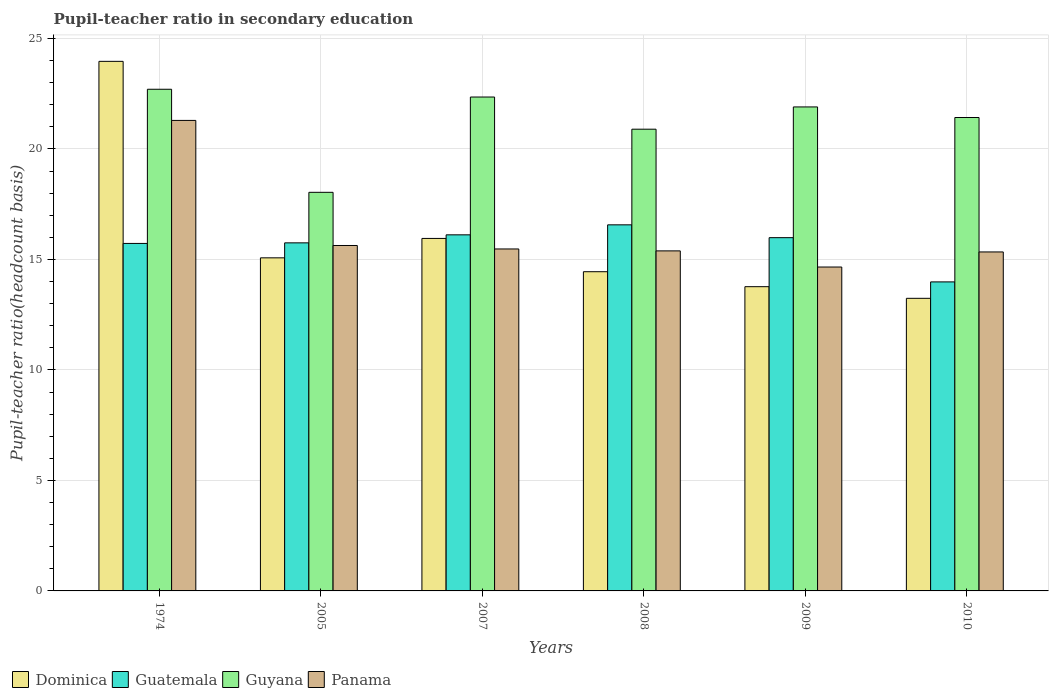How many different coloured bars are there?
Provide a succinct answer. 4. How many bars are there on the 2nd tick from the left?
Give a very brief answer. 4. How many bars are there on the 6th tick from the right?
Keep it short and to the point. 4. What is the label of the 5th group of bars from the left?
Your response must be concise. 2009. In how many cases, is the number of bars for a given year not equal to the number of legend labels?
Ensure brevity in your answer.  0. What is the pupil-teacher ratio in secondary education in Guatemala in 2010?
Your response must be concise. 13.98. Across all years, what is the maximum pupil-teacher ratio in secondary education in Panama?
Offer a very short reply. 21.29. Across all years, what is the minimum pupil-teacher ratio in secondary education in Guatemala?
Offer a terse response. 13.98. In which year was the pupil-teacher ratio in secondary education in Panama maximum?
Your answer should be very brief. 1974. What is the total pupil-teacher ratio in secondary education in Guatemala in the graph?
Your response must be concise. 94.12. What is the difference between the pupil-teacher ratio in secondary education in Panama in 2007 and that in 2010?
Your answer should be compact. 0.14. What is the difference between the pupil-teacher ratio in secondary education in Panama in 2010 and the pupil-teacher ratio in secondary education in Guatemala in 1974?
Make the answer very short. -0.39. What is the average pupil-teacher ratio in secondary education in Dominica per year?
Ensure brevity in your answer.  16.07. In the year 2008, what is the difference between the pupil-teacher ratio in secondary education in Dominica and pupil-teacher ratio in secondary education in Panama?
Ensure brevity in your answer.  -0.94. What is the ratio of the pupil-teacher ratio in secondary education in Guatemala in 2009 to that in 2010?
Provide a succinct answer. 1.14. Is the difference between the pupil-teacher ratio in secondary education in Dominica in 2008 and 2009 greater than the difference between the pupil-teacher ratio in secondary education in Panama in 2008 and 2009?
Keep it short and to the point. No. What is the difference between the highest and the second highest pupil-teacher ratio in secondary education in Guyana?
Give a very brief answer. 0.35. What is the difference between the highest and the lowest pupil-teacher ratio in secondary education in Guatemala?
Your answer should be very brief. 2.58. What does the 4th bar from the left in 2009 represents?
Give a very brief answer. Panama. What does the 2nd bar from the right in 2010 represents?
Your response must be concise. Guyana. Is it the case that in every year, the sum of the pupil-teacher ratio in secondary education in Dominica and pupil-teacher ratio in secondary education in Guatemala is greater than the pupil-teacher ratio in secondary education in Guyana?
Provide a succinct answer. Yes. Are all the bars in the graph horizontal?
Your answer should be compact. No. How many years are there in the graph?
Ensure brevity in your answer.  6. Are the values on the major ticks of Y-axis written in scientific E-notation?
Your answer should be very brief. No. How are the legend labels stacked?
Give a very brief answer. Horizontal. What is the title of the graph?
Offer a very short reply. Pupil-teacher ratio in secondary education. Does "Guatemala" appear as one of the legend labels in the graph?
Your answer should be very brief. Yes. What is the label or title of the X-axis?
Keep it short and to the point. Years. What is the label or title of the Y-axis?
Make the answer very short. Pupil-teacher ratio(headcount basis). What is the Pupil-teacher ratio(headcount basis) of Dominica in 1974?
Give a very brief answer. 23.96. What is the Pupil-teacher ratio(headcount basis) of Guatemala in 1974?
Provide a short and direct response. 15.72. What is the Pupil-teacher ratio(headcount basis) in Guyana in 1974?
Ensure brevity in your answer.  22.7. What is the Pupil-teacher ratio(headcount basis) of Panama in 1974?
Make the answer very short. 21.29. What is the Pupil-teacher ratio(headcount basis) of Dominica in 2005?
Your answer should be compact. 15.07. What is the Pupil-teacher ratio(headcount basis) in Guatemala in 2005?
Offer a terse response. 15.75. What is the Pupil-teacher ratio(headcount basis) in Guyana in 2005?
Make the answer very short. 18.04. What is the Pupil-teacher ratio(headcount basis) in Panama in 2005?
Provide a succinct answer. 15.63. What is the Pupil-teacher ratio(headcount basis) of Dominica in 2007?
Offer a terse response. 15.95. What is the Pupil-teacher ratio(headcount basis) in Guatemala in 2007?
Provide a succinct answer. 16.11. What is the Pupil-teacher ratio(headcount basis) of Guyana in 2007?
Give a very brief answer. 22.35. What is the Pupil-teacher ratio(headcount basis) of Panama in 2007?
Keep it short and to the point. 15.47. What is the Pupil-teacher ratio(headcount basis) of Dominica in 2008?
Provide a succinct answer. 14.44. What is the Pupil-teacher ratio(headcount basis) in Guatemala in 2008?
Offer a very short reply. 16.57. What is the Pupil-teacher ratio(headcount basis) in Guyana in 2008?
Provide a short and direct response. 20.89. What is the Pupil-teacher ratio(headcount basis) in Panama in 2008?
Your answer should be compact. 15.39. What is the Pupil-teacher ratio(headcount basis) in Dominica in 2009?
Give a very brief answer. 13.77. What is the Pupil-teacher ratio(headcount basis) of Guatemala in 2009?
Provide a short and direct response. 15.99. What is the Pupil-teacher ratio(headcount basis) in Guyana in 2009?
Provide a short and direct response. 21.9. What is the Pupil-teacher ratio(headcount basis) in Panama in 2009?
Provide a short and direct response. 14.66. What is the Pupil-teacher ratio(headcount basis) in Dominica in 2010?
Your answer should be compact. 13.24. What is the Pupil-teacher ratio(headcount basis) in Guatemala in 2010?
Provide a succinct answer. 13.98. What is the Pupil-teacher ratio(headcount basis) in Guyana in 2010?
Your response must be concise. 21.42. What is the Pupil-teacher ratio(headcount basis) of Panama in 2010?
Ensure brevity in your answer.  15.34. Across all years, what is the maximum Pupil-teacher ratio(headcount basis) of Dominica?
Your answer should be compact. 23.96. Across all years, what is the maximum Pupil-teacher ratio(headcount basis) of Guatemala?
Offer a very short reply. 16.57. Across all years, what is the maximum Pupil-teacher ratio(headcount basis) in Guyana?
Keep it short and to the point. 22.7. Across all years, what is the maximum Pupil-teacher ratio(headcount basis) in Panama?
Make the answer very short. 21.29. Across all years, what is the minimum Pupil-teacher ratio(headcount basis) in Dominica?
Offer a terse response. 13.24. Across all years, what is the minimum Pupil-teacher ratio(headcount basis) in Guatemala?
Offer a very short reply. 13.98. Across all years, what is the minimum Pupil-teacher ratio(headcount basis) in Guyana?
Give a very brief answer. 18.04. Across all years, what is the minimum Pupil-teacher ratio(headcount basis) in Panama?
Your response must be concise. 14.66. What is the total Pupil-teacher ratio(headcount basis) of Dominica in the graph?
Your answer should be compact. 96.44. What is the total Pupil-teacher ratio(headcount basis) in Guatemala in the graph?
Provide a succinct answer. 94.12. What is the total Pupil-teacher ratio(headcount basis) of Guyana in the graph?
Your answer should be very brief. 127.3. What is the total Pupil-teacher ratio(headcount basis) in Panama in the graph?
Your answer should be compact. 97.78. What is the difference between the Pupil-teacher ratio(headcount basis) in Dominica in 1974 and that in 2005?
Keep it short and to the point. 8.89. What is the difference between the Pupil-teacher ratio(headcount basis) of Guatemala in 1974 and that in 2005?
Your answer should be very brief. -0.03. What is the difference between the Pupil-teacher ratio(headcount basis) in Guyana in 1974 and that in 2005?
Make the answer very short. 4.66. What is the difference between the Pupil-teacher ratio(headcount basis) of Panama in 1974 and that in 2005?
Ensure brevity in your answer.  5.66. What is the difference between the Pupil-teacher ratio(headcount basis) of Dominica in 1974 and that in 2007?
Your response must be concise. 8.01. What is the difference between the Pupil-teacher ratio(headcount basis) of Guatemala in 1974 and that in 2007?
Make the answer very short. -0.39. What is the difference between the Pupil-teacher ratio(headcount basis) in Guyana in 1974 and that in 2007?
Provide a short and direct response. 0.35. What is the difference between the Pupil-teacher ratio(headcount basis) of Panama in 1974 and that in 2007?
Keep it short and to the point. 5.82. What is the difference between the Pupil-teacher ratio(headcount basis) of Dominica in 1974 and that in 2008?
Your answer should be very brief. 9.52. What is the difference between the Pupil-teacher ratio(headcount basis) of Guatemala in 1974 and that in 2008?
Give a very brief answer. -0.84. What is the difference between the Pupil-teacher ratio(headcount basis) in Guyana in 1974 and that in 2008?
Keep it short and to the point. 1.81. What is the difference between the Pupil-teacher ratio(headcount basis) of Panama in 1974 and that in 2008?
Give a very brief answer. 5.9. What is the difference between the Pupil-teacher ratio(headcount basis) of Dominica in 1974 and that in 2009?
Keep it short and to the point. 10.2. What is the difference between the Pupil-teacher ratio(headcount basis) in Guatemala in 1974 and that in 2009?
Keep it short and to the point. -0.26. What is the difference between the Pupil-teacher ratio(headcount basis) of Guyana in 1974 and that in 2009?
Offer a very short reply. 0.8. What is the difference between the Pupil-teacher ratio(headcount basis) in Panama in 1974 and that in 2009?
Ensure brevity in your answer.  6.63. What is the difference between the Pupil-teacher ratio(headcount basis) of Dominica in 1974 and that in 2010?
Your response must be concise. 10.72. What is the difference between the Pupil-teacher ratio(headcount basis) of Guatemala in 1974 and that in 2010?
Your answer should be compact. 1.74. What is the difference between the Pupil-teacher ratio(headcount basis) in Guyana in 1974 and that in 2010?
Your answer should be compact. 1.28. What is the difference between the Pupil-teacher ratio(headcount basis) in Panama in 1974 and that in 2010?
Provide a succinct answer. 5.95. What is the difference between the Pupil-teacher ratio(headcount basis) of Dominica in 2005 and that in 2007?
Your answer should be very brief. -0.88. What is the difference between the Pupil-teacher ratio(headcount basis) of Guatemala in 2005 and that in 2007?
Provide a short and direct response. -0.36. What is the difference between the Pupil-teacher ratio(headcount basis) in Guyana in 2005 and that in 2007?
Give a very brief answer. -4.31. What is the difference between the Pupil-teacher ratio(headcount basis) in Panama in 2005 and that in 2007?
Your answer should be very brief. 0.16. What is the difference between the Pupil-teacher ratio(headcount basis) of Dominica in 2005 and that in 2008?
Offer a terse response. 0.63. What is the difference between the Pupil-teacher ratio(headcount basis) in Guatemala in 2005 and that in 2008?
Provide a succinct answer. -0.82. What is the difference between the Pupil-teacher ratio(headcount basis) of Guyana in 2005 and that in 2008?
Your response must be concise. -2.86. What is the difference between the Pupil-teacher ratio(headcount basis) in Panama in 2005 and that in 2008?
Provide a succinct answer. 0.24. What is the difference between the Pupil-teacher ratio(headcount basis) in Dominica in 2005 and that in 2009?
Your response must be concise. 1.31. What is the difference between the Pupil-teacher ratio(headcount basis) of Guatemala in 2005 and that in 2009?
Offer a very short reply. -0.24. What is the difference between the Pupil-teacher ratio(headcount basis) in Guyana in 2005 and that in 2009?
Keep it short and to the point. -3.86. What is the difference between the Pupil-teacher ratio(headcount basis) in Panama in 2005 and that in 2009?
Provide a short and direct response. 0.97. What is the difference between the Pupil-teacher ratio(headcount basis) of Dominica in 2005 and that in 2010?
Provide a succinct answer. 1.83. What is the difference between the Pupil-teacher ratio(headcount basis) in Guatemala in 2005 and that in 2010?
Make the answer very short. 1.77. What is the difference between the Pupil-teacher ratio(headcount basis) of Guyana in 2005 and that in 2010?
Make the answer very short. -3.39. What is the difference between the Pupil-teacher ratio(headcount basis) of Panama in 2005 and that in 2010?
Make the answer very short. 0.29. What is the difference between the Pupil-teacher ratio(headcount basis) of Dominica in 2007 and that in 2008?
Make the answer very short. 1.51. What is the difference between the Pupil-teacher ratio(headcount basis) of Guatemala in 2007 and that in 2008?
Give a very brief answer. -0.45. What is the difference between the Pupil-teacher ratio(headcount basis) in Guyana in 2007 and that in 2008?
Ensure brevity in your answer.  1.46. What is the difference between the Pupil-teacher ratio(headcount basis) of Panama in 2007 and that in 2008?
Provide a succinct answer. 0.09. What is the difference between the Pupil-teacher ratio(headcount basis) in Dominica in 2007 and that in 2009?
Your answer should be very brief. 2.18. What is the difference between the Pupil-teacher ratio(headcount basis) in Guatemala in 2007 and that in 2009?
Your answer should be compact. 0.13. What is the difference between the Pupil-teacher ratio(headcount basis) of Guyana in 2007 and that in 2009?
Offer a very short reply. 0.45. What is the difference between the Pupil-teacher ratio(headcount basis) of Panama in 2007 and that in 2009?
Your answer should be very brief. 0.82. What is the difference between the Pupil-teacher ratio(headcount basis) of Dominica in 2007 and that in 2010?
Give a very brief answer. 2.71. What is the difference between the Pupil-teacher ratio(headcount basis) in Guatemala in 2007 and that in 2010?
Provide a short and direct response. 2.13. What is the difference between the Pupil-teacher ratio(headcount basis) of Guyana in 2007 and that in 2010?
Offer a terse response. 0.93. What is the difference between the Pupil-teacher ratio(headcount basis) in Panama in 2007 and that in 2010?
Make the answer very short. 0.14. What is the difference between the Pupil-teacher ratio(headcount basis) in Dominica in 2008 and that in 2009?
Provide a short and direct response. 0.68. What is the difference between the Pupil-teacher ratio(headcount basis) in Guatemala in 2008 and that in 2009?
Offer a terse response. 0.58. What is the difference between the Pupil-teacher ratio(headcount basis) of Guyana in 2008 and that in 2009?
Your response must be concise. -1.01. What is the difference between the Pupil-teacher ratio(headcount basis) of Panama in 2008 and that in 2009?
Ensure brevity in your answer.  0.73. What is the difference between the Pupil-teacher ratio(headcount basis) in Dominica in 2008 and that in 2010?
Ensure brevity in your answer.  1.2. What is the difference between the Pupil-teacher ratio(headcount basis) in Guatemala in 2008 and that in 2010?
Make the answer very short. 2.58. What is the difference between the Pupil-teacher ratio(headcount basis) in Guyana in 2008 and that in 2010?
Keep it short and to the point. -0.53. What is the difference between the Pupil-teacher ratio(headcount basis) of Panama in 2008 and that in 2010?
Keep it short and to the point. 0.05. What is the difference between the Pupil-teacher ratio(headcount basis) of Dominica in 2009 and that in 2010?
Provide a short and direct response. 0.53. What is the difference between the Pupil-teacher ratio(headcount basis) in Guatemala in 2009 and that in 2010?
Provide a short and direct response. 2. What is the difference between the Pupil-teacher ratio(headcount basis) in Guyana in 2009 and that in 2010?
Your answer should be very brief. 0.48. What is the difference between the Pupil-teacher ratio(headcount basis) in Panama in 2009 and that in 2010?
Provide a succinct answer. -0.68. What is the difference between the Pupil-teacher ratio(headcount basis) in Dominica in 1974 and the Pupil-teacher ratio(headcount basis) in Guatemala in 2005?
Provide a succinct answer. 8.21. What is the difference between the Pupil-teacher ratio(headcount basis) in Dominica in 1974 and the Pupil-teacher ratio(headcount basis) in Guyana in 2005?
Your response must be concise. 5.93. What is the difference between the Pupil-teacher ratio(headcount basis) in Dominica in 1974 and the Pupil-teacher ratio(headcount basis) in Panama in 2005?
Give a very brief answer. 8.33. What is the difference between the Pupil-teacher ratio(headcount basis) in Guatemala in 1974 and the Pupil-teacher ratio(headcount basis) in Guyana in 2005?
Your response must be concise. -2.31. What is the difference between the Pupil-teacher ratio(headcount basis) of Guatemala in 1974 and the Pupil-teacher ratio(headcount basis) of Panama in 2005?
Offer a terse response. 0.09. What is the difference between the Pupil-teacher ratio(headcount basis) of Guyana in 1974 and the Pupil-teacher ratio(headcount basis) of Panama in 2005?
Your response must be concise. 7.07. What is the difference between the Pupil-teacher ratio(headcount basis) of Dominica in 1974 and the Pupil-teacher ratio(headcount basis) of Guatemala in 2007?
Provide a succinct answer. 7.85. What is the difference between the Pupil-teacher ratio(headcount basis) of Dominica in 1974 and the Pupil-teacher ratio(headcount basis) of Guyana in 2007?
Your answer should be compact. 1.61. What is the difference between the Pupil-teacher ratio(headcount basis) of Dominica in 1974 and the Pupil-teacher ratio(headcount basis) of Panama in 2007?
Offer a very short reply. 8.49. What is the difference between the Pupil-teacher ratio(headcount basis) in Guatemala in 1974 and the Pupil-teacher ratio(headcount basis) in Guyana in 2007?
Provide a short and direct response. -6.62. What is the difference between the Pupil-teacher ratio(headcount basis) in Guatemala in 1974 and the Pupil-teacher ratio(headcount basis) in Panama in 2007?
Provide a succinct answer. 0.25. What is the difference between the Pupil-teacher ratio(headcount basis) of Guyana in 1974 and the Pupil-teacher ratio(headcount basis) of Panama in 2007?
Provide a short and direct response. 7.23. What is the difference between the Pupil-teacher ratio(headcount basis) in Dominica in 1974 and the Pupil-teacher ratio(headcount basis) in Guatemala in 2008?
Provide a short and direct response. 7.4. What is the difference between the Pupil-teacher ratio(headcount basis) of Dominica in 1974 and the Pupil-teacher ratio(headcount basis) of Guyana in 2008?
Your answer should be very brief. 3.07. What is the difference between the Pupil-teacher ratio(headcount basis) of Dominica in 1974 and the Pupil-teacher ratio(headcount basis) of Panama in 2008?
Provide a short and direct response. 8.58. What is the difference between the Pupil-teacher ratio(headcount basis) of Guatemala in 1974 and the Pupil-teacher ratio(headcount basis) of Guyana in 2008?
Your response must be concise. -5.17. What is the difference between the Pupil-teacher ratio(headcount basis) in Guatemala in 1974 and the Pupil-teacher ratio(headcount basis) in Panama in 2008?
Make the answer very short. 0.34. What is the difference between the Pupil-teacher ratio(headcount basis) in Guyana in 1974 and the Pupil-teacher ratio(headcount basis) in Panama in 2008?
Your answer should be compact. 7.31. What is the difference between the Pupil-teacher ratio(headcount basis) of Dominica in 1974 and the Pupil-teacher ratio(headcount basis) of Guatemala in 2009?
Your answer should be compact. 7.98. What is the difference between the Pupil-teacher ratio(headcount basis) of Dominica in 1974 and the Pupil-teacher ratio(headcount basis) of Guyana in 2009?
Offer a very short reply. 2.06. What is the difference between the Pupil-teacher ratio(headcount basis) in Dominica in 1974 and the Pupil-teacher ratio(headcount basis) in Panama in 2009?
Give a very brief answer. 9.31. What is the difference between the Pupil-teacher ratio(headcount basis) in Guatemala in 1974 and the Pupil-teacher ratio(headcount basis) in Guyana in 2009?
Keep it short and to the point. -6.18. What is the difference between the Pupil-teacher ratio(headcount basis) of Guatemala in 1974 and the Pupil-teacher ratio(headcount basis) of Panama in 2009?
Ensure brevity in your answer.  1.07. What is the difference between the Pupil-teacher ratio(headcount basis) of Guyana in 1974 and the Pupil-teacher ratio(headcount basis) of Panama in 2009?
Your answer should be compact. 8.04. What is the difference between the Pupil-teacher ratio(headcount basis) of Dominica in 1974 and the Pupil-teacher ratio(headcount basis) of Guatemala in 2010?
Give a very brief answer. 9.98. What is the difference between the Pupil-teacher ratio(headcount basis) of Dominica in 1974 and the Pupil-teacher ratio(headcount basis) of Guyana in 2010?
Give a very brief answer. 2.54. What is the difference between the Pupil-teacher ratio(headcount basis) in Dominica in 1974 and the Pupil-teacher ratio(headcount basis) in Panama in 2010?
Keep it short and to the point. 8.62. What is the difference between the Pupil-teacher ratio(headcount basis) of Guatemala in 1974 and the Pupil-teacher ratio(headcount basis) of Guyana in 2010?
Give a very brief answer. -5.7. What is the difference between the Pupil-teacher ratio(headcount basis) in Guatemala in 1974 and the Pupil-teacher ratio(headcount basis) in Panama in 2010?
Offer a very short reply. 0.39. What is the difference between the Pupil-teacher ratio(headcount basis) in Guyana in 1974 and the Pupil-teacher ratio(headcount basis) in Panama in 2010?
Offer a very short reply. 7.36. What is the difference between the Pupil-teacher ratio(headcount basis) in Dominica in 2005 and the Pupil-teacher ratio(headcount basis) in Guatemala in 2007?
Your response must be concise. -1.04. What is the difference between the Pupil-teacher ratio(headcount basis) in Dominica in 2005 and the Pupil-teacher ratio(headcount basis) in Guyana in 2007?
Keep it short and to the point. -7.28. What is the difference between the Pupil-teacher ratio(headcount basis) of Dominica in 2005 and the Pupil-teacher ratio(headcount basis) of Panama in 2007?
Give a very brief answer. -0.4. What is the difference between the Pupil-teacher ratio(headcount basis) in Guatemala in 2005 and the Pupil-teacher ratio(headcount basis) in Guyana in 2007?
Your answer should be very brief. -6.6. What is the difference between the Pupil-teacher ratio(headcount basis) in Guatemala in 2005 and the Pupil-teacher ratio(headcount basis) in Panama in 2007?
Offer a terse response. 0.28. What is the difference between the Pupil-teacher ratio(headcount basis) in Guyana in 2005 and the Pupil-teacher ratio(headcount basis) in Panama in 2007?
Provide a short and direct response. 2.56. What is the difference between the Pupil-teacher ratio(headcount basis) of Dominica in 2005 and the Pupil-teacher ratio(headcount basis) of Guatemala in 2008?
Provide a short and direct response. -1.49. What is the difference between the Pupil-teacher ratio(headcount basis) in Dominica in 2005 and the Pupil-teacher ratio(headcount basis) in Guyana in 2008?
Ensure brevity in your answer.  -5.82. What is the difference between the Pupil-teacher ratio(headcount basis) in Dominica in 2005 and the Pupil-teacher ratio(headcount basis) in Panama in 2008?
Provide a succinct answer. -0.31. What is the difference between the Pupil-teacher ratio(headcount basis) of Guatemala in 2005 and the Pupil-teacher ratio(headcount basis) of Guyana in 2008?
Make the answer very short. -5.14. What is the difference between the Pupil-teacher ratio(headcount basis) in Guatemala in 2005 and the Pupil-teacher ratio(headcount basis) in Panama in 2008?
Keep it short and to the point. 0.36. What is the difference between the Pupil-teacher ratio(headcount basis) in Guyana in 2005 and the Pupil-teacher ratio(headcount basis) in Panama in 2008?
Make the answer very short. 2.65. What is the difference between the Pupil-teacher ratio(headcount basis) of Dominica in 2005 and the Pupil-teacher ratio(headcount basis) of Guatemala in 2009?
Give a very brief answer. -0.91. What is the difference between the Pupil-teacher ratio(headcount basis) of Dominica in 2005 and the Pupil-teacher ratio(headcount basis) of Guyana in 2009?
Your answer should be compact. -6.83. What is the difference between the Pupil-teacher ratio(headcount basis) in Dominica in 2005 and the Pupil-teacher ratio(headcount basis) in Panama in 2009?
Make the answer very short. 0.42. What is the difference between the Pupil-teacher ratio(headcount basis) of Guatemala in 2005 and the Pupil-teacher ratio(headcount basis) of Guyana in 2009?
Your answer should be compact. -6.15. What is the difference between the Pupil-teacher ratio(headcount basis) of Guatemala in 2005 and the Pupil-teacher ratio(headcount basis) of Panama in 2009?
Give a very brief answer. 1.09. What is the difference between the Pupil-teacher ratio(headcount basis) in Guyana in 2005 and the Pupil-teacher ratio(headcount basis) in Panama in 2009?
Keep it short and to the point. 3.38. What is the difference between the Pupil-teacher ratio(headcount basis) of Dominica in 2005 and the Pupil-teacher ratio(headcount basis) of Guatemala in 2010?
Give a very brief answer. 1.09. What is the difference between the Pupil-teacher ratio(headcount basis) in Dominica in 2005 and the Pupil-teacher ratio(headcount basis) in Guyana in 2010?
Make the answer very short. -6.35. What is the difference between the Pupil-teacher ratio(headcount basis) in Dominica in 2005 and the Pupil-teacher ratio(headcount basis) in Panama in 2010?
Give a very brief answer. -0.27. What is the difference between the Pupil-teacher ratio(headcount basis) in Guatemala in 2005 and the Pupil-teacher ratio(headcount basis) in Guyana in 2010?
Ensure brevity in your answer.  -5.67. What is the difference between the Pupil-teacher ratio(headcount basis) of Guatemala in 2005 and the Pupil-teacher ratio(headcount basis) of Panama in 2010?
Your response must be concise. 0.41. What is the difference between the Pupil-teacher ratio(headcount basis) in Guyana in 2005 and the Pupil-teacher ratio(headcount basis) in Panama in 2010?
Provide a succinct answer. 2.7. What is the difference between the Pupil-teacher ratio(headcount basis) in Dominica in 2007 and the Pupil-teacher ratio(headcount basis) in Guatemala in 2008?
Provide a short and direct response. -0.61. What is the difference between the Pupil-teacher ratio(headcount basis) in Dominica in 2007 and the Pupil-teacher ratio(headcount basis) in Guyana in 2008?
Give a very brief answer. -4.94. What is the difference between the Pupil-teacher ratio(headcount basis) of Dominica in 2007 and the Pupil-teacher ratio(headcount basis) of Panama in 2008?
Provide a short and direct response. 0.56. What is the difference between the Pupil-teacher ratio(headcount basis) of Guatemala in 2007 and the Pupil-teacher ratio(headcount basis) of Guyana in 2008?
Your response must be concise. -4.78. What is the difference between the Pupil-teacher ratio(headcount basis) of Guatemala in 2007 and the Pupil-teacher ratio(headcount basis) of Panama in 2008?
Offer a terse response. 0.73. What is the difference between the Pupil-teacher ratio(headcount basis) of Guyana in 2007 and the Pupil-teacher ratio(headcount basis) of Panama in 2008?
Provide a succinct answer. 6.96. What is the difference between the Pupil-teacher ratio(headcount basis) in Dominica in 2007 and the Pupil-teacher ratio(headcount basis) in Guatemala in 2009?
Provide a short and direct response. -0.03. What is the difference between the Pupil-teacher ratio(headcount basis) of Dominica in 2007 and the Pupil-teacher ratio(headcount basis) of Guyana in 2009?
Offer a terse response. -5.95. What is the difference between the Pupil-teacher ratio(headcount basis) of Dominica in 2007 and the Pupil-teacher ratio(headcount basis) of Panama in 2009?
Your answer should be very brief. 1.29. What is the difference between the Pupil-teacher ratio(headcount basis) of Guatemala in 2007 and the Pupil-teacher ratio(headcount basis) of Guyana in 2009?
Make the answer very short. -5.79. What is the difference between the Pupil-teacher ratio(headcount basis) in Guatemala in 2007 and the Pupil-teacher ratio(headcount basis) in Panama in 2009?
Ensure brevity in your answer.  1.46. What is the difference between the Pupil-teacher ratio(headcount basis) of Guyana in 2007 and the Pupil-teacher ratio(headcount basis) of Panama in 2009?
Ensure brevity in your answer.  7.69. What is the difference between the Pupil-teacher ratio(headcount basis) of Dominica in 2007 and the Pupil-teacher ratio(headcount basis) of Guatemala in 2010?
Offer a very short reply. 1.97. What is the difference between the Pupil-teacher ratio(headcount basis) in Dominica in 2007 and the Pupil-teacher ratio(headcount basis) in Guyana in 2010?
Ensure brevity in your answer.  -5.47. What is the difference between the Pupil-teacher ratio(headcount basis) in Dominica in 2007 and the Pupil-teacher ratio(headcount basis) in Panama in 2010?
Ensure brevity in your answer.  0.61. What is the difference between the Pupil-teacher ratio(headcount basis) of Guatemala in 2007 and the Pupil-teacher ratio(headcount basis) of Guyana in 2010?
Keep it short and to the point. -5.31. What is the difference between the Pupil-teacher ratio(headcount basis) in Guatemala in 2007 and the Pupil-teacher ratio(headcount basis) in Panama in 2010?
Keep it short and to the point. 0.77. What is the difference between the Pupil-teacher ratio(headcount basis) of Guyana in 2007 and the Pupil-teacher ratio(headcount basis) of Panama in 2010?
Provide a succinct answer. 7.01. What is the difference between the Pupil-teacher ratio(headcount basis) in Dominica in 2008 and the Pupil-teacher ratio(headcount basis) in Guatemala in 2009?
Provide a short and direct response. -1.54. What is the difference between the Pupil-teacher ratio(headcount basis) of Dominica in 2008 and the Pupil-teacher ratio(headcount basis) of Guyana in 2009?
Keep it short and to the point. -7.46. What is the difference between the Pupil-teacher ratio(headcount basis) of Dominica in 2008 and the Pupil-teacher ratio(headcount basis) of Panama in 2009?
Your answer should be very brief. -0.21. What is the difference between the Pupil-teacher ratio(headcount basis) of Guatemala in 2008 and the Pupil-teacher ratio(headcount basis) of Guyana in 2009?
Your answer should be very brief. -5.34. What is the difference between the Pupil-teacher ratio(headcount basis) of Guatemala in 2008 and the Pupil-teacher ratio(headcount basis) of Panama in 2009?
Give a very brief answer. 1.91. What is the difference between the Pupil-teacher ratio(headcount basis) in Guyana in 2008 and the Pupil-teacher ratio(headcount basis) in Panama in 2009?
Provide a short and direct response. 6.24. What is the difference between the Pupil-teacher ratio(headcount basis) in Dominica in 2008 and the Pupil-teacher ratio(headcount basis) in Guatemala in 2010?
Provide a short and direct response. 0.46. What is the difference between the Pupil-teacher ratio(headcount basis) in Dominica in 2008 and the Pupil-teacher ratio(headcount basis) in Guyana in 2010?
Your response must be concise. -6.98. What is the difference between the Pupil-teacher ratio(headcount basis) in Dominica in 2008 and the Pupil-teacher ratio(headcount basis) in Panama in 2010?
Offer a very short reply. -0.89. What is the difference between the Pupil-teacher ratio(headcount basis) in Guatemala in 2008 and the Pupil-teacher ratio(headcount basis) in Guyana in 2010?
Your answer should be compact. -4.86. What is the difference between the Pupil-teacher ratio(headcount basis) in Guatemala in 2008 and the Pupil-teacher ratio(headcount basis) in Panama in 2010?
Ensure brevity in your answer.  1.23. What is the difference between the Pupil-teacher ratio(headcount basis) in Guyana in 2008 and the Pupil-teacher ratio(headcount basis) in Panama in 2010?
Offer a very short reply. 5.55. What is the difference between the Pupil-teacher ratio(headcount basis) in Dominica in 2009 and the Pupil-teacher ratio(headcount basis) in Guatemala in 2010?
Offer a very short reply. -0.22. What is the difference between the Pupil-teacher ratio(headcount basis) of Dominica in 2009 and the Pupil-teacher ratio(headcount basis) of Guyana in 2010?
Offer a very short reply. -7.66. What is the difference between the Pupil-teacher ratio(headcount basis) in Dominica in 2009 and the Pupil-teacher ratio(headcount basis) in Panama in 2010?
Your response must be concise. -1.57. What is the difference between the Pupil-teacher ratio(headcount basis) in Guatemala in 2009 and the Pupil-teacher ratio(headcount basis) in Guyana in 2010?
Provide a succinct answer. -5.44. What is the difference between the Pupil-teacher ratio(headcount basis) in Guatemala in 2009 and the Pupil-teacher ratio(headcount basis) in Panama in 2010?
Keep it short and to the point. 0.65. What is the difference between the Pupil-teacher ratio(headcount basis) of Guyana in 2009 and the Pupil-teacher ratio(headcount basis) of Panama in 2010?
Make the answer very short. 6.56. What is the average Pupil-teacher ratio(headcount basis) of Dominica per year?
Give a very brief answer. 16.07. What is the average Pupil-teacher ratio(headcount basis) of Guatemala per year?
Your response must be concise. 15.69. What is the average Pupil-teacher ratio(headcount basis) of Guyana per year?
Offer a very short reply. 21.22. What is the average Pupil-teacher ratio(headcount basis) of Panama per year?
Your answer should be very brief. 16.3. In the year 1974, what is the difference between the Pupil-teacher ratio(headcount basis) in Dominica and Pupil-teacher ratio(headcount basis) in Guatemala?
Make the answer very short. 8.24. In the year 1974, what is the difference between the Pupil-teacher ratio(headcount basis) in Dominica and Pupil-teacher ratio(headcount basis) in Guyana?
Give a very brief answer. 1.26. In the year 1974, what is the difference between the Pupil-teacher ratio(headcount basis) of Dominica and Pupil-teacher ratio(headcount basis) of Panama?
Offer a terse response. 2.67. In the year 1974, what is the difference between the Pupil-teacher ratio(headcount basis) in Guatemala and Pupil-teacher ratio(headcount basis) in Guyana?
Make the answer very short. -6.98. In the year 1974, what is the difference between the Pupil-teacher ratio(headcount basis) in Guatemala and Pupil-teacher ratio(headcount basis) in Panama?
Provide a succinct answer. -5.57. In the year 1974, what is the difference between the Pupil-teacher ratio(headcount basis) in Guyana and Pupil-teacher ratio(headcount basis) in Panama?
Provide a succinct answer. 1.41. In the year 2005, what is the difference between the Pupil-teacher ratio(headcount basis) of Dominica and Pupil-teacher ratio(headcount basis) of Guatemala?
Keep it short and to the point. -0.68. In the year 2005, what is the difference between the Pupil-teacher ratio(headcount basis) in Dominica and Pupil-teacher ratio(headcount basis) in Guyana?
Ensure brevity in your answer.  -2.96. In the year 2005, what is the difference between the Pupil-teacher ratio(headcount basis) in Dominica and Pupil-teacher ratio(headcount basis) in Panama?
Keep it short and to the point. -0.56. In the year 2005, what is the difference between the Pupil-teacher ratio(headcount basis) in Guatemala and Pupil-teacher ratio(headcount basis) in Guyana?
Your response must be concise. -2.29. In the year 2005, what is the difference between the Pupil-teacher ratio(headcount basis) in Guatemala and Pupil-teacher ratio(headcount basis) in Panama?
Make the answer very short. 0.12. In the year 2005, what is the difference between the Pupil-teacher ratio(headcount basis) in Guyana and Pupil-teacher ratio(headcount basis) in Panama?
Your response must be concise. 2.41. In the year 2007, what is the difference between the Pupil-teacher ratio(headcount basis) of Dominica and Pupil-teacher ratio(headcount basis) of Guatemala?
Give a very brief answer. -0.16. In the year 2007, what is the difference between the Pupil-teacher ratio(headcount basis) in Dominica and Pupil-teacher ratio(headcount basis) in Guyana?
Your answer should be very brief. -6.4. In the year 2007, what is the difference between the Pupil-teacher ratio(headcount basis) in Dominica and Pupil-teacher ratio(headcount basis) in Panama?
Your response must be concise. 0.48. In the year 2007, what is the difference between the Pupil-teacher ratio(headcount basis) in Guatemala and Pupil-teacher ratio(headcount basis) in Guyana?
Offer a terse response. -6.24. In the year 2007, what is the difference between the Pupil-teacher ratio(headcount basis) of Guatemala and Pupil-teacher ratio(headcount basis) of Panama?
Keep it short and to the point. 0.64. In the year 2007, what is the difference between the Pupil-teacher ratio(headcount basis) in Guyana and Pupil-teacher ratio(headcount basis) in Panama?
Offer a very short reply. 6.87. In the year 2008, what is the difference between the Pupil-teacher ratio(headcount basis) in Dominica and Pupil-teacher ratio(headcount basis) in Guatemala?
Your answer should be compact. -2.12. In the year 2008, what is the difference between the Pupil-teacher ratio(headcount basis) of Dominica and Pupil-teacher ratio(headcount basis) of Guyana?
Keep it short and to the point. -6.45. In the year 2008, what is the difference between the Pupil-teacher ratio(headcount basis) of Dominica and Pupil-teacher ratio(headcount basis) of Panama?
Offer a terse response. -0.94. In the year 2008, what is the difference between the Pupil-teacher ratio(headcount basis) in Guatemala and Pupil-teacher ratio(headcount basis) in Guyana?
Your answer should be compact. -4.33. In the year 2008, what is the difference between the Pupil-teacher ratio(headcount basis) in Guatemala and Pupil-teacher ratio(headcount basis) in Panama?
Provide a succinct answer. 1.18. In the year 2008, what is the difference between the Pupil-teacher ratio(headcount basis) in Guyana and Pupil-teacher ratio(headcount basis) in Panama?
Keep it short and to the point. 5.51. In the year 2009, what is the difference between the Pupil-teacher ratio(headcount basis) in Dominica and Pupil-teacher ratio(headcount basis) in Guatemala?
Offer a terse response. -2.22. In the year 2009, what is the difference between the Pupil-teacher ratio(headcount basis) in Dominica and Pupil-teacher ratio(headcount basis) in Guyana?
Give a very brief answer. -8.13. In the year 2009, what is the difference between the Pupil-teacher ratio(headcount basis) in Dominica and Pupil-teacher ratio(headcount basis) in Panama?
Keep it short and to the point. -0.89. In the year 2009, what is the difference between the Pupil-teacher ratio(headcount basis) in Guatemala and Pupil-teacher ratio(headcount basis) in Guyana?
Provide a short and direct response. -5.92. In the year 2009, what is the difference between the Pupil-teacher ratio(headcount basis) of Guatemala and Pupil-teacher ratio(headcount basis) of Panama?
Your answer should be very brief. 1.33. In the year 2009, what is the difference between the Pupil-teacher ratio(headcount basis) of Guyana and Pupil-teacher ratio(headcount basis) of Panama?
Keep it short and to the point. 7.24. In the year 2010, what is the difference between the Pupil-teacher ratio(headcount basis) in Dominica and Pupil-teacher ratio(headcount basis) in Guatemala?
Your answer should be compact. -0.74. In the year 2010, what is the difference between the Pupil-teacher ratio(headcount basis) of Dominica and Pupil-teacher ratio(headcount basis) of Guyana?
Provide a succinct answer. -8.18. In the year 2010, what is the difference between the Pupil-teacher ratio(headcount basis) in Dominica and Pupil-teacher ratio(headcount basis) in Panama?
Give a very brief answer. -2.1. In the year 2010, what is the difference between the Pupil-teacher ratio(headcount basis) in Guatemala and Pupil-teacher ratio(headcount basis) in Guyana?
Offer a very short reply. -7.44. In the year 2010, what is the difference between the Pupil-teacher ratio(headcount basis) in Guatemala and Pupil-teacher ratio(headcount basis) in Panama?
Offer a terse response. -1.36. In the year 2010, what is the difference between the Pupil-teacher ratio(headcount basis) in Guyana and Pupil-teacher ratio(headcount basis) in Panama?
Offer a terse response. 6.08. What is the ratio of the Pupil-teacher ratio(headcount basis) of Dominica in 1974 to that in 2005?
Make the answer very short. 1.59. What is the ratio of the Pupil-teacher ratio(headcount basis) in Guatemala in 1974 to that in 2005?
Provide a short and direct response. 1. What is the ratio of the Pupil-teacher ratio(headcount basis) in Guyana in 1974 to that in 2005?
Provide a short and direct response. 1.26. What is the ratio of the Pupil-teacher ratio(headcount basis) of Panama in 1974 to that in 2005?
Make the answer very short. 1.36. What is the ratio of the Pupil-teacher ratio(headcount basis) in Dominica in 1974 to that in 2007?
Your answer should be compact. 1.5. What is the ratio of the Pupil-teacher ratio(headcount basis) in Guatemala in 1974 to that in 2007?
Keep it short and to the point. 0.98. What is the ratio of the Pupil-teacher ratio(headcount basis) in Guyana in 1974 to that in 2007?
Ensure brevity in your answer.  1.02. What is the ratio of the Pupil-teacher ratio(headcount basis) in Panama in 1974 to that in 2007?
Ensure brevity in your answer.  1.38. What is the ratio of the Pupil-teacher ratio(headcount basis) in Dominica in 1974 to that in 2008?
Offer a very short reply. 1.66. What is the ratio of the Pupil-teacher ratio(headcount basis) of Guatemala in 1974 to that in 2008?
Provide a short and direct response. 0.95. What is the ratio of the Pupil-teacher ratio(headcount basis) of Guyana in 1974 to that in 2008?
Make the answer very short. 1.09. What is the ratio of the Pupil-teacher ratio(headcount basis) of Panama in 1974 to that in 2008?
Keep it short and to the point. 1.38. What is the ratio of the Pupil-teacher ratio(headcount basis) of Dominica in 1974 to that in 2009?
Offer a terse response. 1.74. What is the ratio of the Pupil-teacher ratio(headcount basis) in Guatemala in 1974 to that in 2009?
Keep it short and to the point. 0.98. What is the ratio of the Pupil-teacher ratio(headcount basis) of Guyana in 1974 to that in 2009?
Make the answer very short. 1.04. What is the ratio of the Pupil-teacher ratio(headcount basis) in Panama in 1974 to that in 2009?
Provide a short and direct response. 1.45. What is the ratio of the Pupil-teacher ratio(headcount basis) in Dominica in 1974 to that in 2010?
Your answer should be compact. 1.81. What is the ratio of the Pupil-teacher ratio(headcount basis) in Guatemala in 1974 to that in 2010?
Keep it short and to the point. 1.12. What is the ratio of the Pupil-teacher ratio(headcount basis) of Guyana in 1974 to that in 2010?
Keep it short and to the point. 1.06. What is the ratio of the Pupil-teacher ratio(headcount basis) of Panama in 1974 to that in 2010?
Ensure brevity in your answer.  1.39. What is the ratio of the Pupil-teacher ratio(headcount basis) of Dominica in 2005 to that in 2007?
Make the answer very short. 0.94. What is the ratio of the Pupil-teacher ratio(headcount basis) of Guatemala in 2005 to that in 2007?
Provide a short and direct response. 0.98. What is the ratio of the Pupil-teacher ratio(headcount basis) of Guyana in 2005 to that in 2007?
Offer a very short reply. 0.81. What is the ratio of the Pupil-teacher ratio(headcount basis) of Dominica in 2005 to that in 2008?
Keep it short and to the point. 1.04. What is the ratio of the Pupil-teacher ratio(headcount basis) of Guatemala in 2005 to that in 2008?
Keep it short and to the point. 0.95. What is the ratio of the Pupil-teacher ratio(headcount basis) of Guyana in 2005 to that in 2008?
Offer a terse response. 0.86. What is the ratio of the Pupil-teacher ratio(headcount basis) in Panama in 2005 to that in 2008?
Make the answer very short. 1.02. What is the ratio of the Pupil-teacher ratio(headcount basis) of Dominica in 2005 to that in 2009?
Your response must be concise. 1.09. What is the ratio of the Pupil-teacher ratio(headcount basis) of Guatemala in 2005 to that in 2009?
Provide a succinct answer. 0.99. What is the ratio of the Pupil-teacher ratio(headcount basis) of Guyana in 2005 to that in 2009?
Provide a short and direct response. 0.82. What is the ratio of the Pupil-teacher ratio(headcount basis) in Panama in 2005 to that in 2009?
Make the answer very short. 1.07. What is the ratio of the Pupil-teacher ratio(headcount basis) of Dominica in 2005 to that in 2010?
Give a very brief answer. 1.14. What is the ratio of the Pupil-teacher ratio(headcount basis) of Guatemala in 2005 to that in 2010?
Your answer should be compact. 1.13. What is the ratio of the Pupil-teacher ratio(headcount basis) of Guyana in 2005 to that in 2010?
Offer a very short reply. 0.84. What is the ratio of the Pupil-teacher ratio(headcount basis) in Panama in 2005 to that in 2010?
Give a very brief answer. 1.02. What is the ratio of the Pupil-teacher ratio(headcount basis) in Dominica in 2007 to that in 2008?
Offer a terse response. 1.1. What is the ratio of the Pupil-teacher ratio(headcount basis) in Guatemala in 2007 to that in 2008?
Your answer should be compact. 0.97. What is the ratio of the Pupil-teacher ratio(headcount basis) in Guyana in 2007 to that in 2008?
Give a very brief answer. 1.07. What is the ratio of the Pupil-teacher ratio(headcount basis) in Panama in 2007 to that in 2008?
Ensure brevity in your answer.  1.01. What is the ratio of the Pupil-teacher ratio(headcount basis) in Dominica in 2007 to that in 2009?
Give a very brief answer. 1.16. What is the ratio of the Pupil-teacher ratio(headcount basis) of Guyana in 2007 to that in 2009?
Your answer should be very brief. 1.02. What is the ratio of the Pupil-teacher ratio(headcount basis) of Panama in 2007 to that in 2009?
Offer a terse response. 1.06. What is the ratio of the Pupil-teacher ratio(headcount basis) of Dominica in 2007 to that in 2010?
Your response must be concise. 1.2. What is the ratio of the Pupil-teacher ratio(headcount basis) in Guatemala in 2007 to that in 2010?
Ensure brevity in your answer.  1.15. What is the ratio of the Pupil-teacher ratio(headcount basis) in Guyana in 2007 to that in 2010?
Provide a short and direct response. 1.04. What is the ratio of the Pupil-teacher ratio(headcount basis) in Panama in 2007 to that in 2010?
Your answer should be very brief. 1.01. What is the ratio of the Pupil-teacher ratio(headcount basis) of Dominica in 2008 to that in 2009?
Provide a short and direct response. 1.05. What is the ratio of the Pupil-teacher ratio(headcount basis) of Guatemala in 2008 to that in 2009?
Offer a very short reply. 1.04. What is the ratio of the Pupil-teacher ratio(headcount basis) in Guyana in 2008 to that in 2009?
Give a very brief answer. 0.95. What is the ratio of the Pupil-teacher ratio(headcount basis) in Panama in 2008 to that in 2009?
Make the answer very short. 1.05. What is the ratio of the Pupil-teacher ratio(headcount basis) in Guatemala in 2008 to that in 2010?
Provide a short and direct response. 1.18. What is the ratio of the Pupil-teacher ratio(headcount basis) of Guyana in 2008 to that in 2010?
Your answer should be very brief. 0.98. What is the ratio of the Pupil-teacher ratio(headcount basis) in Dominica in 2009 to that in 2010?
Keep it short and to the point. 1.04. What is the ratio of the Pupil-teacher ratio(headcount basis) of Guatemala in 2009 to that in 2010?
Your response must be concise. 1.14. What is the ratio of the Pupil-teacher ratio(headcount basis) in Guyana in 2009 to that in 2010?
Offer a very short reply. 1.02. What is the ratio of the Pupil-teacher ratio(headcount basis) of Panama in 2009 to that in 2010?
Provide a short and direct response. 0.96. What is the difference between the highest and the second highest Pupil-teacher ratio(headcount basis) in Dominica?
Your response must be concise. 8.01. What is the difference between the highest and the second highest Pupil-teacher ratio(headcount basis) in Guatemala?
Ensure brevity in your answer.  0.45. What is the difference between the highest and the second highest Pupil-teacher ratio(headcount basis) in Guyana?
Ensure brevity in your answer.  0.35. What is the difference between the highest and the second highest Pupil-teacher ratio(headcount basis) of Panama?
Offer a very short reply. 5.66. What is the difference between the highest and the lowest Pupil-teacher ratio(headcount basis) in Dominica?
Give a very brief answer. 10.72. What is the difference between the highest and the lowest Pupil-teacher ratio(headcount basis) in Guatemala?
Keep it short and to the point. 2.58. What is the difference between the highest and the lowest Pupil-teacher ratio(headcount basis) in Guyana?
Your answer should be very brief. 4.66. What is the difference between the highest and the lowest Pupil-teacher ratio(headcount basis) in Panama?
Keep it short and to the point. 6.63. 